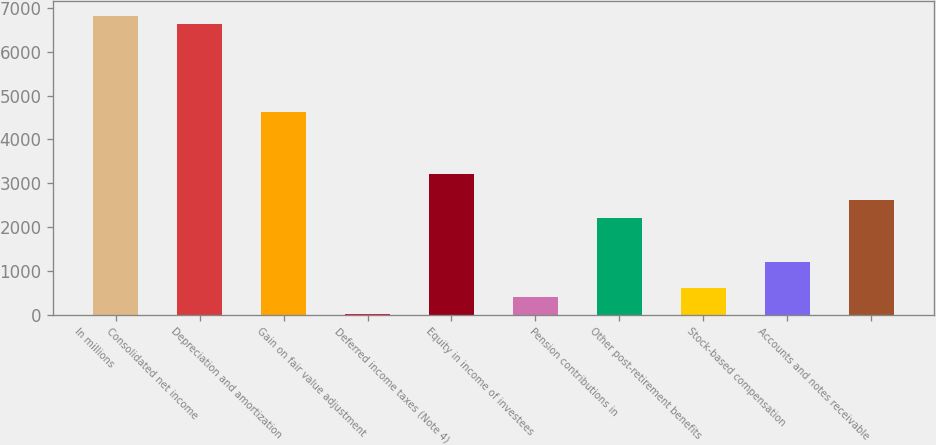<chart> <loc_0><loc_0><loc_500><loc_500><bar_chart><fcel>In millions<fcel>Consolidated net income<fcel>Depreciation and amortization<fcel>Gain on fair value adjustment<fcel>Deferred income taxes (Note 4)<fcel>Equity in income of investees<fcel>Pension contributions in<fcel>Other post-retirement benefits<fcel>Stock-based compensation<fcel>Accounts and notes receivable<nl><fcel>6824<fcel>6623.5<fcel>4618.5<fcel>7<fcel>3215<fcel>408<fcel>2212.5<fcel>608.5<fcel>1210<fcel>2613.5<nl></chart> 